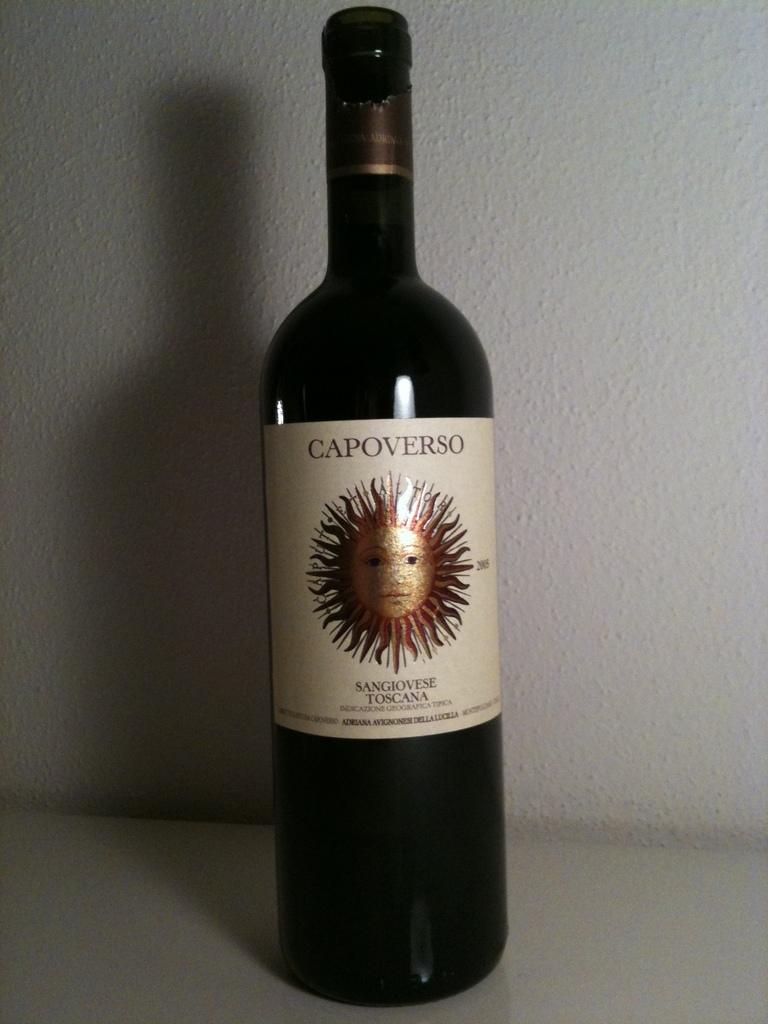Who makes this wine?
Your answer should be compact. Capoverso. 